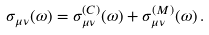Convert formula to latex. <formula><loc_0><loc_0><loc_500><loc_500>\sigma _ { \mu \nu } ( \omega ) = \sigma ^ { ( C ) } _ { \mu \nu } ( \omega ) + \sigma ^ { ( M ) } _ { \mu \nu } ( \omega ) \, .</formula> 